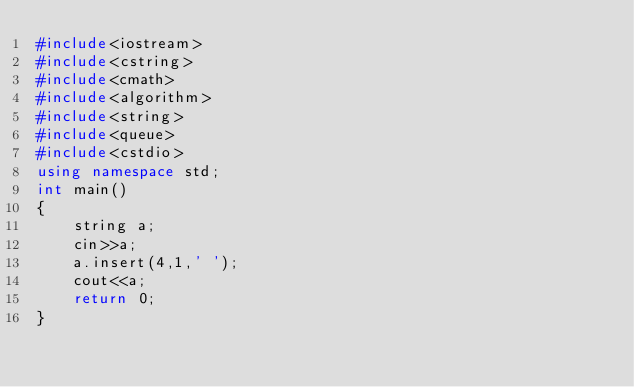Convert code to text. <code><loc_0><loc_0><loc_500><loc_500><_C++_>#include<iostream>
#include<cstring>
#include<cmath>
#include<algorithm>
#include<string>
#include<queue>
#include<cstdio>
using namespace std;
int main()
{
    string a;
    cin>>a;
    a.insert(4,1,' ');
    cout<<a;
	return 0;
}</code> 